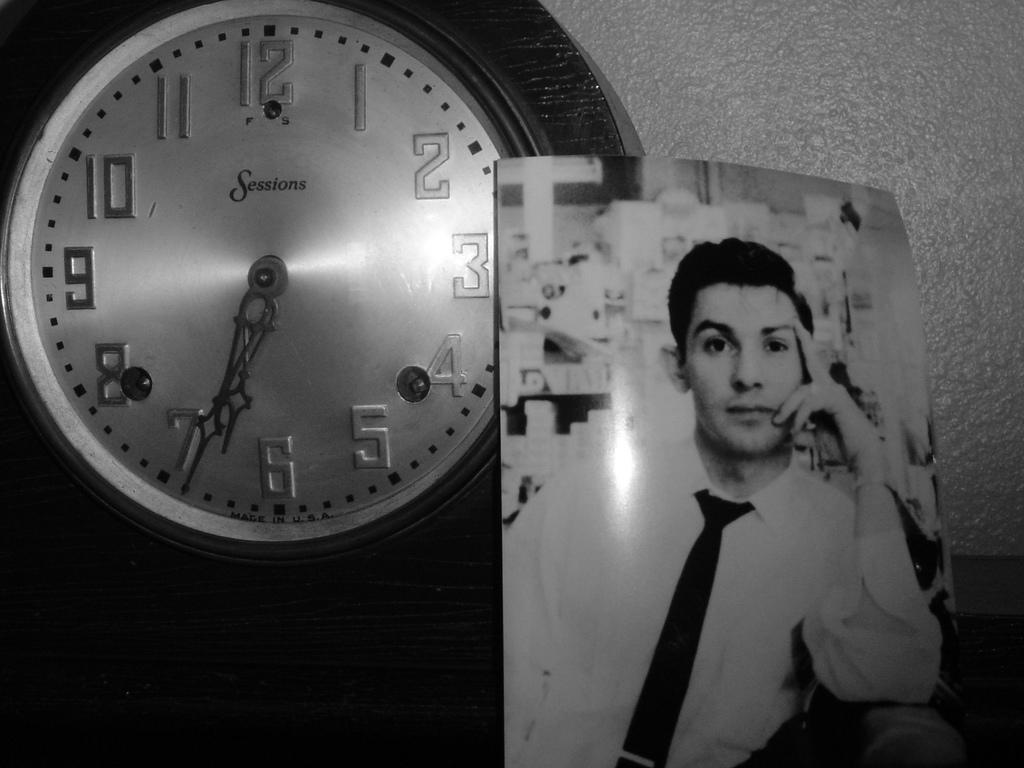<image>
Share a concise interpretation of the image provided. a black and white photo next to a clock with the time after 6:30 